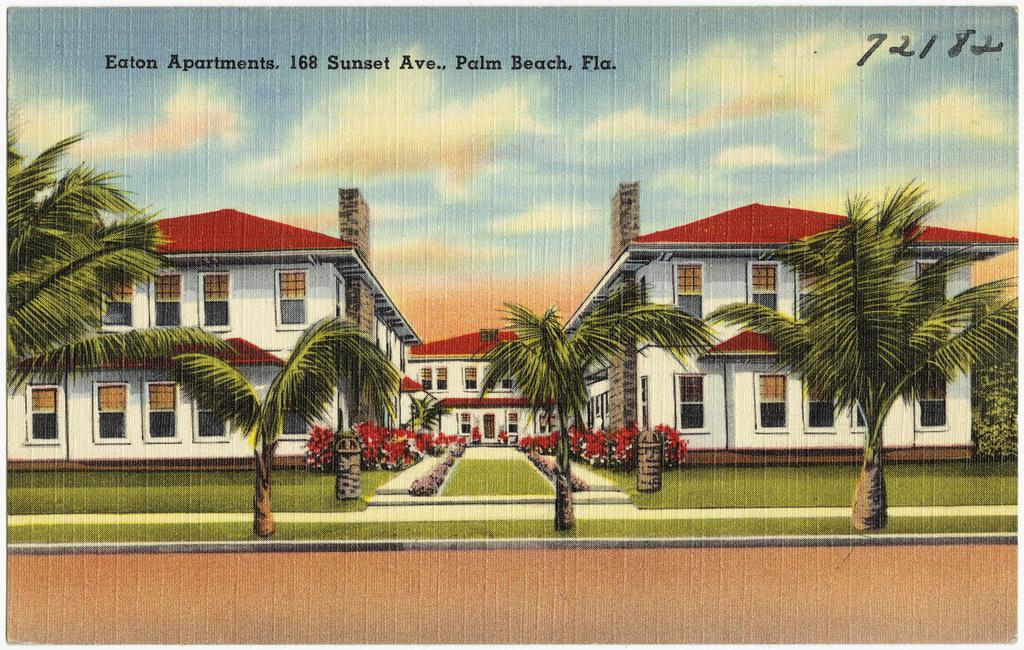What type of structures are depicted in the image? There are depictions of buildings in the image. What other elements can be seen in the image besides the buildings? There are trees and the sky visible in the image. Is there any text present in the image? Yes, there is some text at the top of the image. How many times has the image been copied in the past hour? There is no information about the image being copied in the past hour, so we cannot determine the number of copies made. 